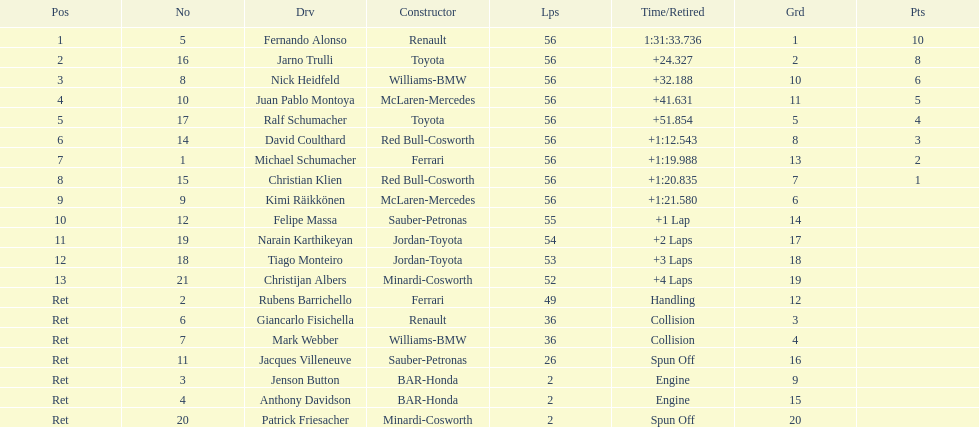How many drivers were retired before the race could end? 7. 